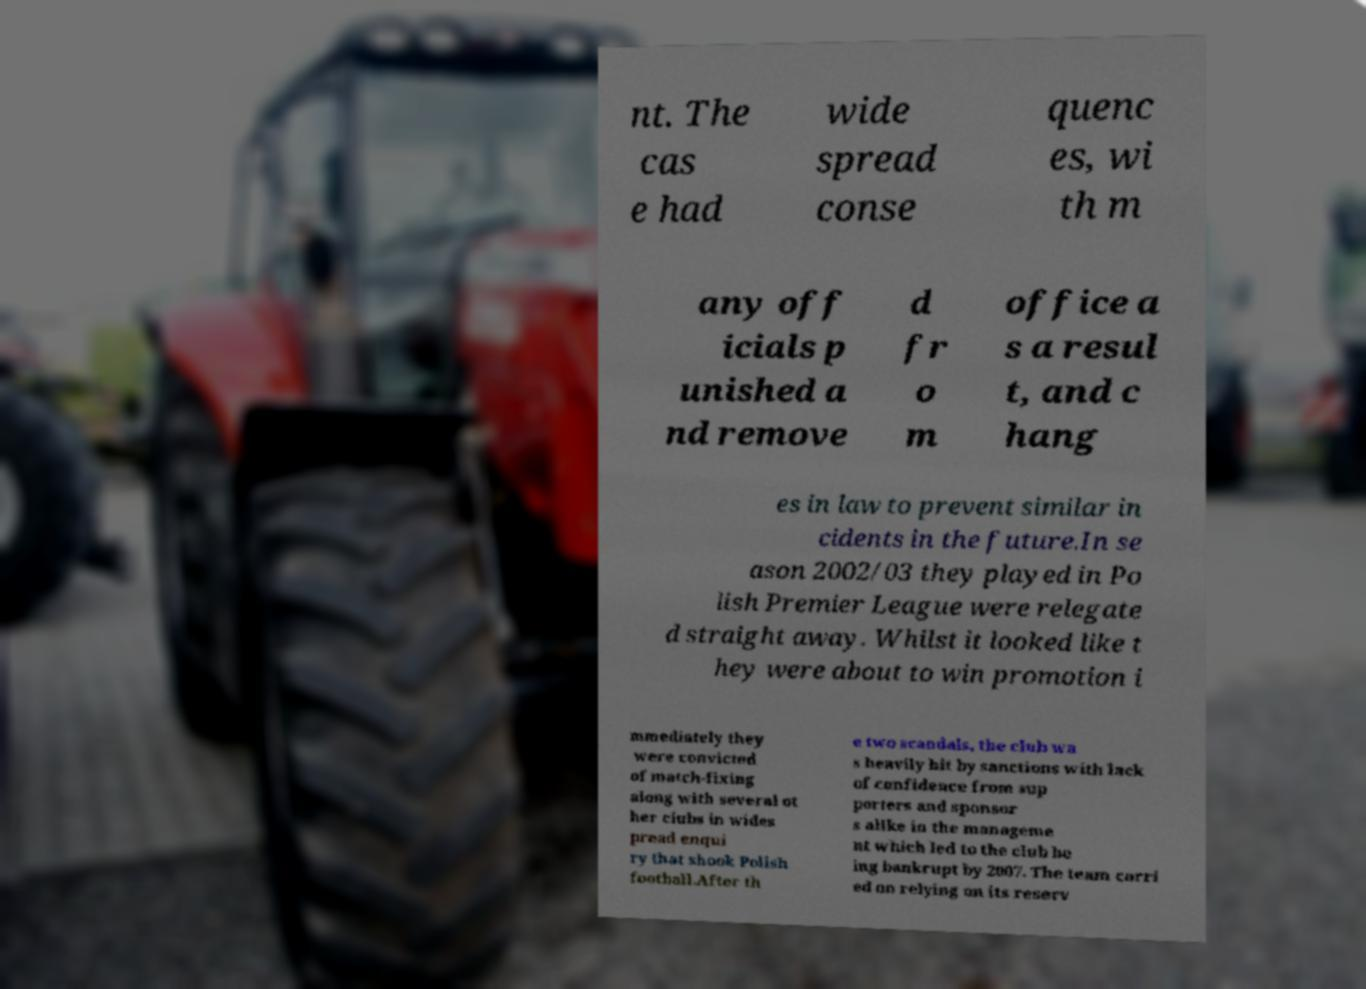What messages or text are displayed in this image? I need them in a readable, typed format. nt. The cas e had wide spread conse quenc es, wi th m any off icials p unished a nd remove d fr o m office a s a resul t, and c hang es in law to prevent similar in cidents in the future.In se ason 2002/03 they played in Po lish Premier League were relegate d straight away. Whilst it looked like t hey were about to win promotion i mmediately they were convicted of match-fixing along with several ot her clubs in wides pread enqui ry that shook Polish football.After th e two scandals, the club wa s heavily hit by sanctions with lack of confidence from sup porters and sponsor s alike in the manageme nt which led to the club be ing bankrupt by 2007. The team carri ed on relying on its reserv 